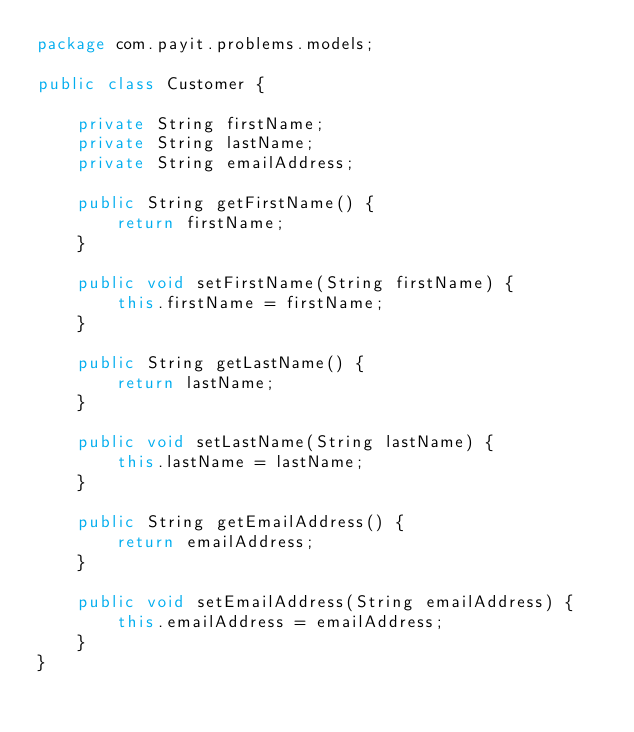Convert code to text. <code><loc_0><loc_0><loc_500><loc_500><_Java_>package com.payit.problems.models;

public class Customer {

    private String firstName;
    private String lastName;
    private String emailAddress;

    public String getFirstName() {
        return firstName;
    }

    public void setFirstName(String firstName) {
        this.firstName = firstName;
    }

    public String getLastName() {
        return lastName;
    }

    public void setLastName(String lastName) {
        this.lastName = lastName;
    }

    public String getEmailAddress() {
        return emailAddress;
    }

    public void setEmailAddress(String emailAddress) {
        this.emailAddress = emailAddress;
    }
}
</code> 